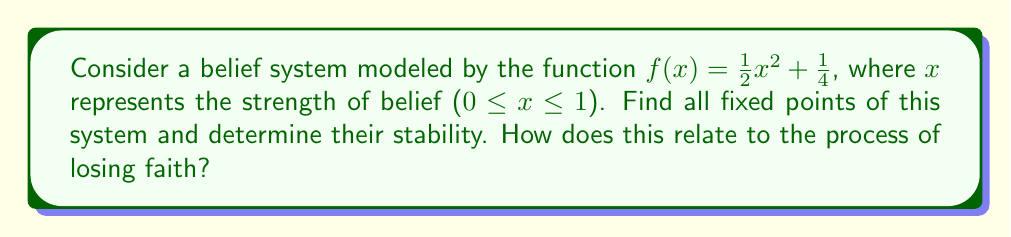Solve this math problem. 1. To find fixed points, we solve the equation $f(x) = x$:
   $$\frac{1}{2}x^2 + \frac{1}{4} = x$$

2. Rearrange the equation:
   $$\frac{1}{2}x^2 - x + \frac{1}{4} = 0$$

3. This is a quadratic equation. Use the quadratic formula $x = \frac{-b \pm \sqrt{b^2 - 4ac}}{2a}$:
   $$x = \frac{1 \pm \sqrt{1 - 4(\frac{1}{2})(\frac{1}{4})}}{2(\frac{1}{2})} = 1 \pm \frac{1}{\sqrt{2}}$$

4. The fixed points are:
   $$x_1 = 1 + \frac{1}{\sqrt{2}} \approx 1.707$$
   $$x_2 = 1 - \frac{1}{\sqrt{2}} \approx 0.293$$

5. To determine stability, we examine $|f'(x)|$ at each fixed point:
   $$f'(x) = x$$

6. For $x_1$:
   $$|f'(x_1)| = |1 + \frac{1}{\sqrt{2}}| > 1$$
   This fixed point is unstable.

7. For $x_2$:
   $$|f'(x_2)| = |1 - \frac{1}{\sqrt{2}}| < 1$$
   This fixed point is stable.

8. Relating to losing faith: The stable fixed point $x_2$ represents a state of weak belief, while the unstable fixed point $x_1$ represents a state of strong belief. The instability of $x_1$ suggests that strong beliefs are more susceptible to change, potentially leading to a loss of faith. Conversely, the stability of $x_2$ indicates that weak beliefs or doubts tend to persist, aligning with the experience of transitioning to atheism.
Answer: Two fixed points: $x_1 = 1 + \frac{1}{\sqrt{2}}$ (unstable), $x_2 = 1 - \frac{1}{\sqrt{2}}$ (stable). 